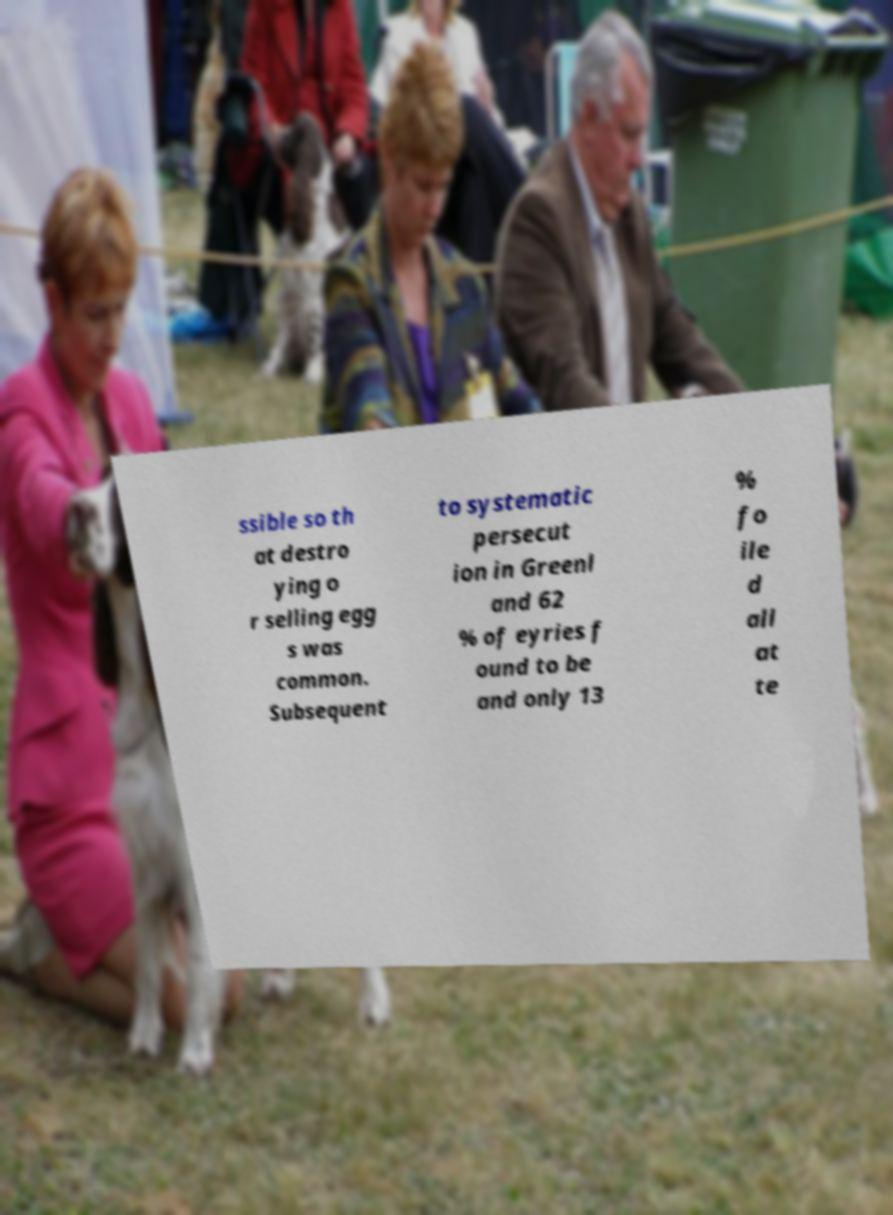Can you read and provide the text displayed in the image?This photo seems to have some interesting text. Can you extract and type it out for me? ssible so th at destro ying o r selling egg s was common. Subsequent to systematic persecut ion in Greenl and 62 % of eyries f ound to be and only 13 % fo ile d all at te 